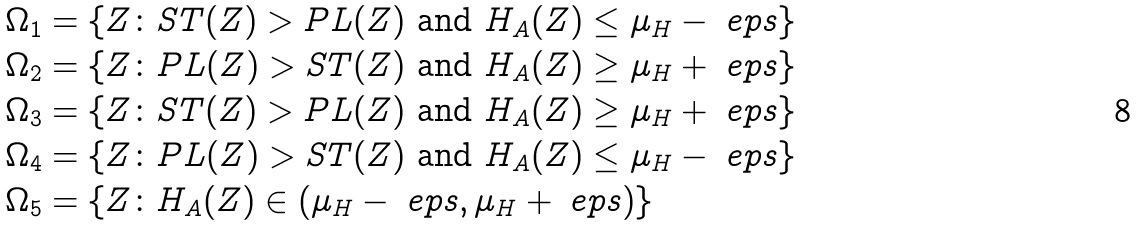<formula> <loc_0><loc_0><loc_500><loc_500>\Omega _ { 1 } & = \{ Z \colon S T ( Z ) > P L ( Z ) \text { and } H _ { A } ( Z ) \leq \mu _ { H } - \ e p s \} \\ \Omega _ { 2 } & = \{ Z \colon P L ( Z ) > S T ( Z ) \text { and } H _ { A } ( Z ) \geq \mu _ { H } + \ e p s \} \\ \Omega _ { 3 } & = \{ Z \colon S T ( Z ) > P L ( Z ) \text { and } H _ { A } ( Z ) \geq \mu _ { H } + \ e p s \} \\ \Omega _ { 4 } & = \{ Z \colon P L ( Z ) > S T ( Z ) \text { and } H _ { A } ( Z ) \leq \mu _ { H } - \ e p s \} \\ \Omega _ { 5 } & = \{ Z \colon H _ { A } ( Z ) \in ( \mu _ { H } - \ e p s , \mu _ { H } + \ e p s ) \}</formula> 